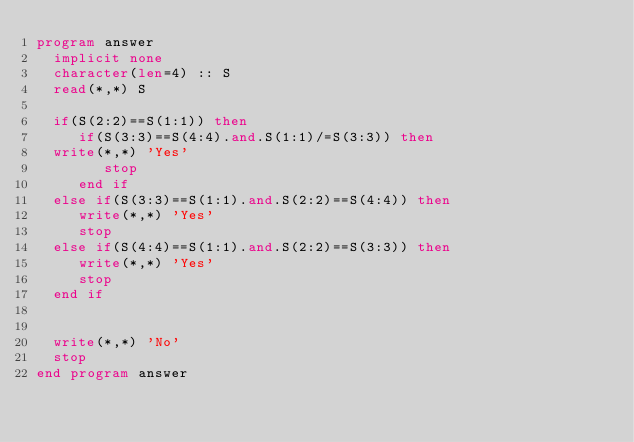<code> <loc_0><loc_0><loc_500><loc_500><_FORTRAN_>program answer
  implicit none
  character(len=4) :: S
  read(*,*) S

  if(S(2:2)==S(1:1)) then
     if(S(3:3)==S(4:4).and.S(1:1)/=S(3:3)) then
	write(*,*) 'Yes'
        stop
     end if
  else if(S(3:3)==S(1:1).and.S(2:2)==S(4:4)) then
     write(*,*) 'Yes'
     stop
  else if(S(4:4)==S(1:1).and.S(2:2)==S(3:3)) then
     write(*,*) 'Yes'
     stop
  end if


  write(*,*) 'No'
  stop
end program answer</code> 